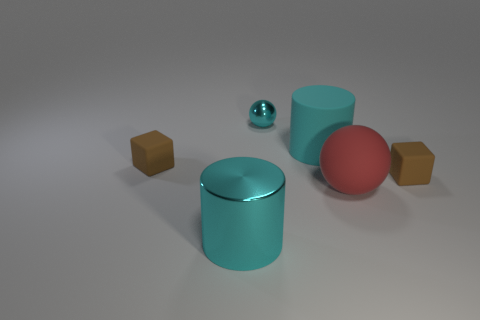Add 3 brown metallic blocks. How many objects exist? 9 Subtract all cubes. How many objects are left? 4 Subtract all red matte spheres. Subtract all blue metal things. How many objects are left? 5 Add 6 tiny blocks. How many tiny blocks are left? 8 Add 6 yellow rubber cubes. How many yellow rubber cubes exist? 6 Subtract 0 yellow blocks. How many objects are left? 6 